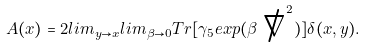Convert formula to latex. <formula><loc_0><loc_0><loc_500><loc_500>A ( x ) = 2 l i m _ { y \rightarrow x } l i m _ { \beta \rightarrow 0 } T r [ \gamma _ { 5 } e x p ( \beta \not \nabla ^ { 2 } ) ] \delta ( x , y ) .</formula> 